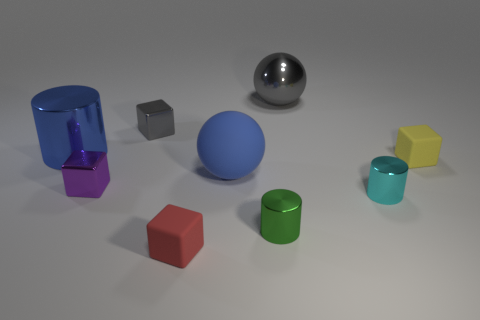Subtract all large blue cylinders. How many cylinders are left? 2 Subtract 1 cubes. How many cubes are left? 3 Add 1 tiny red things. How many objects exist? 10 Subtract all red blocks. How many blocks are left? 3 Subtract all spheres. How many objects are left? 7 Subtract all yellow cylinders. Subtract all cyan balls. How many cylinders are left? 3 Add 3 small metal cylinders. How many small metal cylinders are left? 5 Add 4 tiny yellow matte cubes. How many tiny yellow matte cubes exist? 5 Subtract 0 yellow spheres. How many objects are left? 9 Subtract all tiny red matte cubes. Subtract all small red objects. How many objects are left? 7 